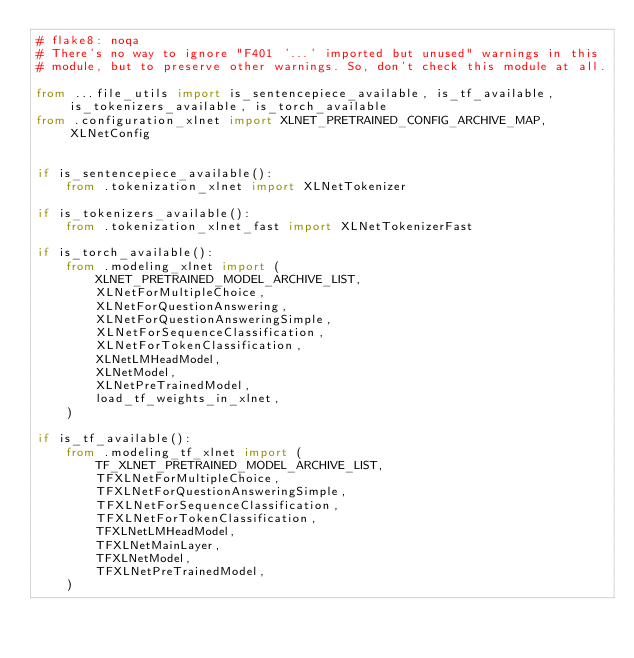Convert code to text. <code><loc_0><loc_0><loc_500><loc_500><_Python_># flake8: noqa
# There's no way to ignore "F401 '...' imported but unused" warnings in this
# module, but to preserve other warnings. So, don't check this module at all.

from ...file_utils import is_sentencepiece_available, is_tf_available, is_tokenizers_available, is_torch_available
from .configuration_xlnet import XLNET_PRETRAINED_CONFIG_ARCHIVE_MAP, XLNetConfig


if is_sentencepiece_available():
    from .tokenization_xlnet import XLNetTokenizer

if is_tokenizers_available():
    from .tokenization_xlnet_fast import XLNetTokenizerFast

if is_torch_available():
    from .modeling_xlnet import (
        XLNET_PRETRAINED_MODEL_ARCHIVE_LIST,
        XLNetForMultipleChoice,
        XLNetForQuestionAnswering,
        XLNetForQuestionAnsweringSimple,
        XLNetForSequenceClassification,
        XLNetForTokenClassification,
        XLNetLMHeadModel,
        XLNetModel,
        XLNetPreTrainedModel,
        load_tf_weights_in_xlnet,
    )

if is_tf_available():
    from .modeling_tf_xlnet import (
        TF_XLNET_PRETRAINED_MODEL_ARCHIVE_LIST,
        TFXLNetForMultipleChoice,
        TFXLNetForQuestionAnsweringSimple,
        TFXLNetForSequenceClassification,
        TFXLNetForTokenClassification,
        TFXLNetLMHeadModel,
        TFXLNetMainLayer,
        TFXLNetModel,
        TFXLNetPreTrainedModel,
    )
</code> 